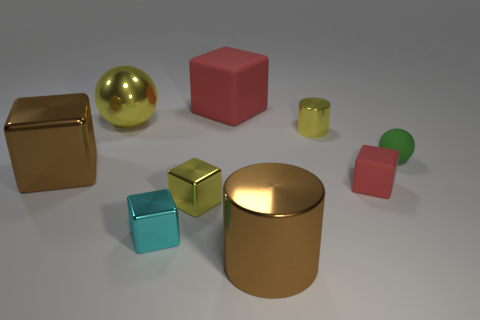What is the material of the yellow thing that is the same shape as the green matte thing?
Make the answer very short. Metal. Is there any other thing that has the same size as the green rubber ball?
Make the answer very short. Yes. How big is the rubber block that is behind the red cube in front of the small yellow cylinder?
Keep it short and to the point. Large. The big rubber block has what color?
Ensure brevity in your answer.  Red. How many brown blocks are behind the sphere on the right side of the yellow metal sphere?
Give a very brief answer. 0. There is a metallic cube to the right of the cyan block; is there a large shiny cylinder that is behind it?
Ensure brevity in your answer.  No. There is a small cyan thing; are there any small cubes in front of it?
Provide a short and direct response. No. Is the shape of the tiny object behind the small green thing the same as  the big red object?
Ensure brevity in your answer.  No. What number of other large things have the same shape as the big yellow object?
Provide a succinct answer. 0. Is there another tiny green thing that has the same material as the tiny green thing?
Provide a short and direct response. No. 